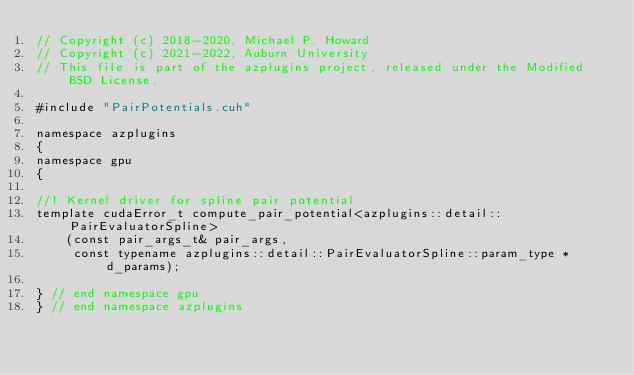Convert code to text. <code><loc_0><loc_0><loc_500><loc_500><_Cuda_>// Copyright (c) 2018-2020, Michael P. Howard
// Copyright (c) 2021-2022, Auburn University
// This file is part of the azplugins project, released under the Modified BSD License.

#include "PairPotentials.cuh"

namespace azplugins
{
namespace gpu
{

//! Kernel driver for spline pair potential
template cudaError_t compute_pair_potential<azplugins::detail::PairEvaluatorSpline>
    (const pair_args_t& pair_args,
     const typename azplugins::detail::PairEvaluatorSpline::param_type *d_params);

} // end namespace gpu
} // end namespace azplugins
</code> 